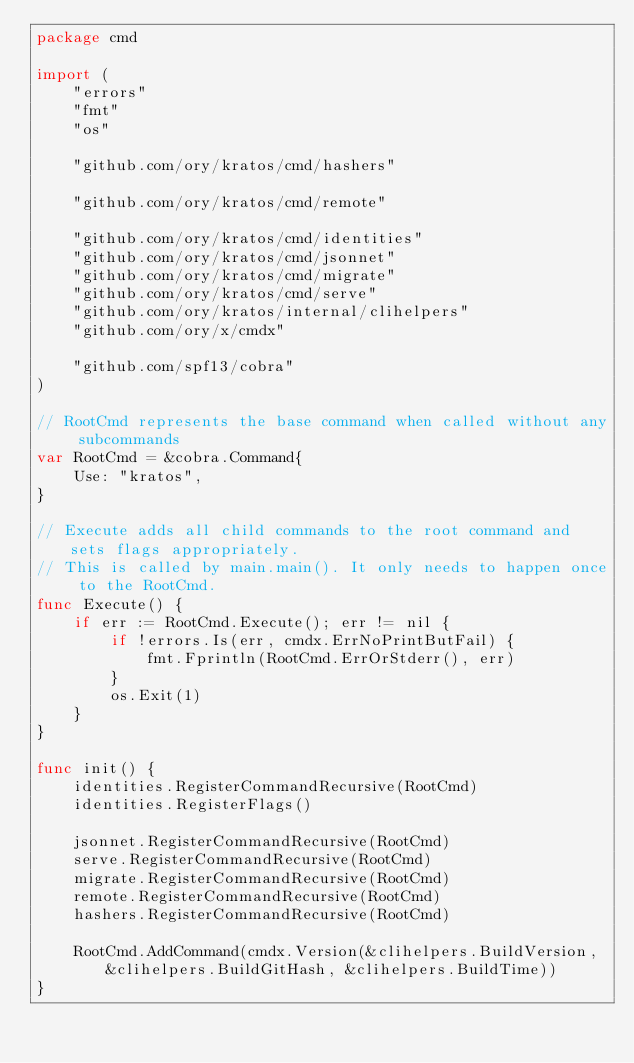Convert code to text. <code><loc_0><loc_0><loc_500><loc_500><_Go_>package cmd

import (
	"errors"
	"fmt"
	"os"

	"github.com/ory/kratos/cmd/hashers"

	"github.com/ory/kratos/cmd/remote"

	"github.com/ory/kratos/cmd/identities"
	"github.com/ory/kratos/cmd/jsonnet"
	"github.com/ory/kratos/cmd/migrate"
	"github.com/ory/kratos/cmd/serve"
	"github.com/ory/kratos/internal/clihelpers"
	"github.com/ory/x/cmdx"

	"github.com/spf13/cobra"
)

// RootCmd represents the base command when called without any subcommands
var RootCmd = &cobra.Command{
	Use: "kratos",
}

// Execute adds all child commands to the root command and sets flags appropriately.
// This is called by main.main(). It only needs to happen once to the RootCmd.
func Execute() {
	if err := RootCmd.Execute(); err != nil {
		if !errors.Is(err, cmdx.ErrNoPrintButFail) {
			fmt.Fprintln(RootCmd.ErrOrStderr(), err)
		}
		os.Exit(1)
	}
}

func init() {
	identities.RegisterCommandRecursive(RootCmd)
	identities.RegisterFlags()

	jsonnet.RegisterCommandRecursive(RootCmd)
	serve.RegisterCommandRecursive(RootCmd)
	migrate.RegisterCommandRecursive(RootCmd)
	remote.RegisterCommandRecursive(RootCmd)
	hashers.RegisterCommandRecursive(RootCmd)

	RootCmd.AddCommand(cmdx.Version(&clihelpers.BuildVersion, &clihelpers.BuildGitHash, &clihelpers.BuildTime))
}
</code> 